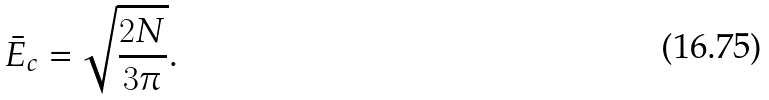Convert formula to latex. <formula><loc_0><loc_0><loc_500><loc_500>\bar { E } _ { c } = \sqrt { \frac { 2 N } { 3 \pi } } .</formula> 